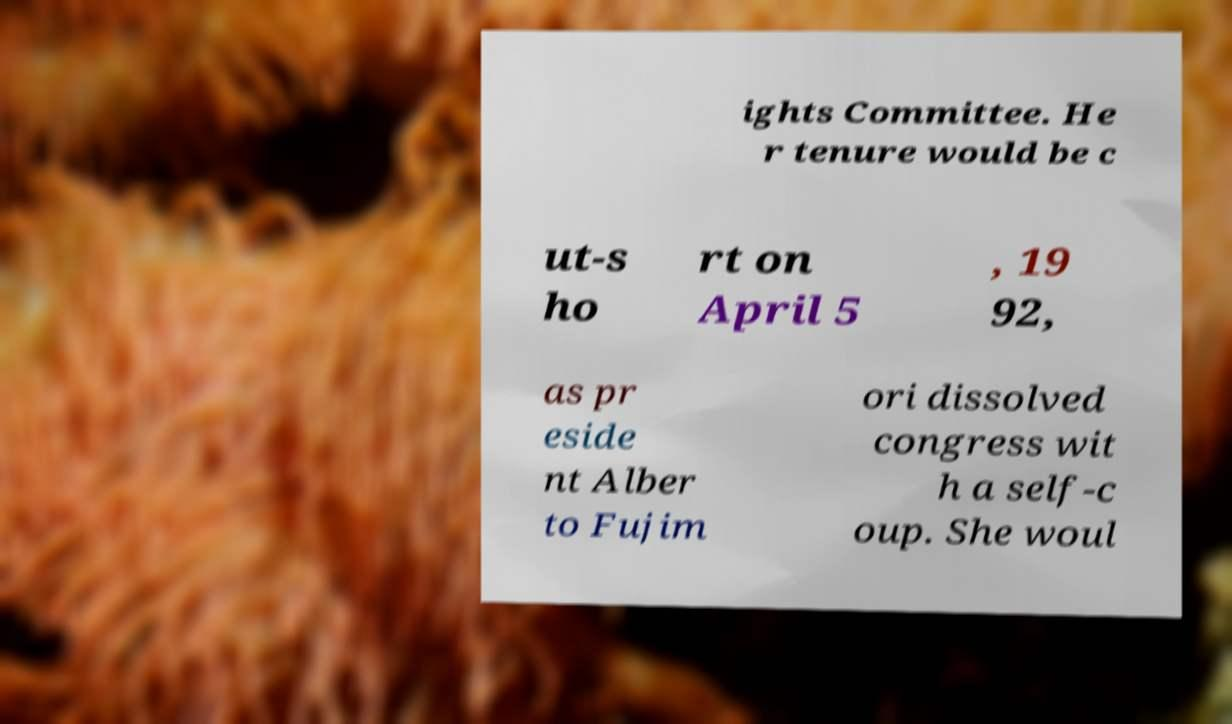Can you read and provide the text displayed in the image?This photo seems to have some interesting text. Can you extract and type it out for me? ights Committee. He r tenure would be c ut-s ho rt on April 5 , 19 92, as pr eside nt Alber to Fujim ori dissolved congress wit h a self-c oup. She woul 